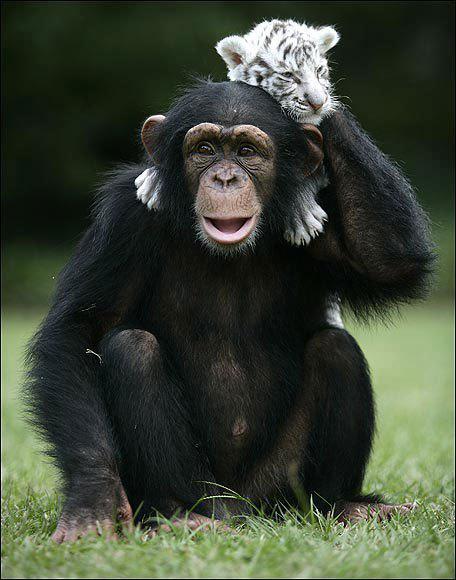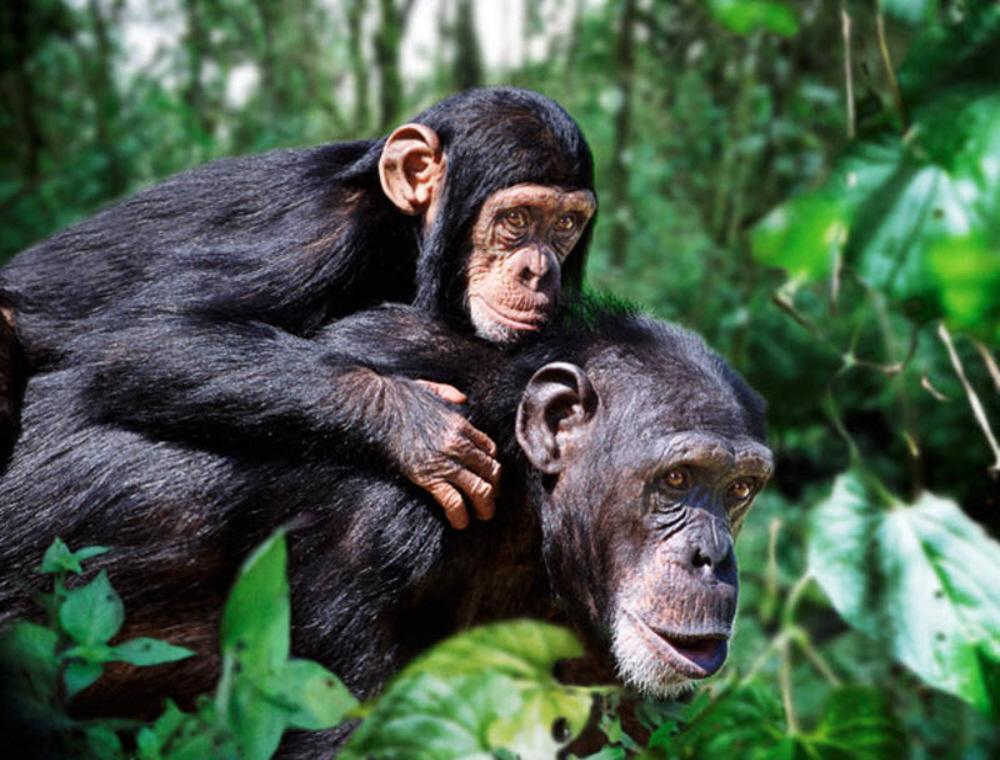The first image is the image on the left, the second image is the image on the right. Given the left and right images, does the statement "A baby ape is riding it's mothers back." hold true? Answer yes or no. Yes. The first image is the image on the left, the second image is the image on the right. Evaluate the accuracy of this statement regarding the images: "One of the images shows one monkey riding on the back of another monkey.". Is it true? Answer yes or no. Yes. The first image is the image on the left, the second image is the image on the right. Given the left and right images, does the statement "a child ape is on its mothers back." hold true? Answer yes or no. Yes. 